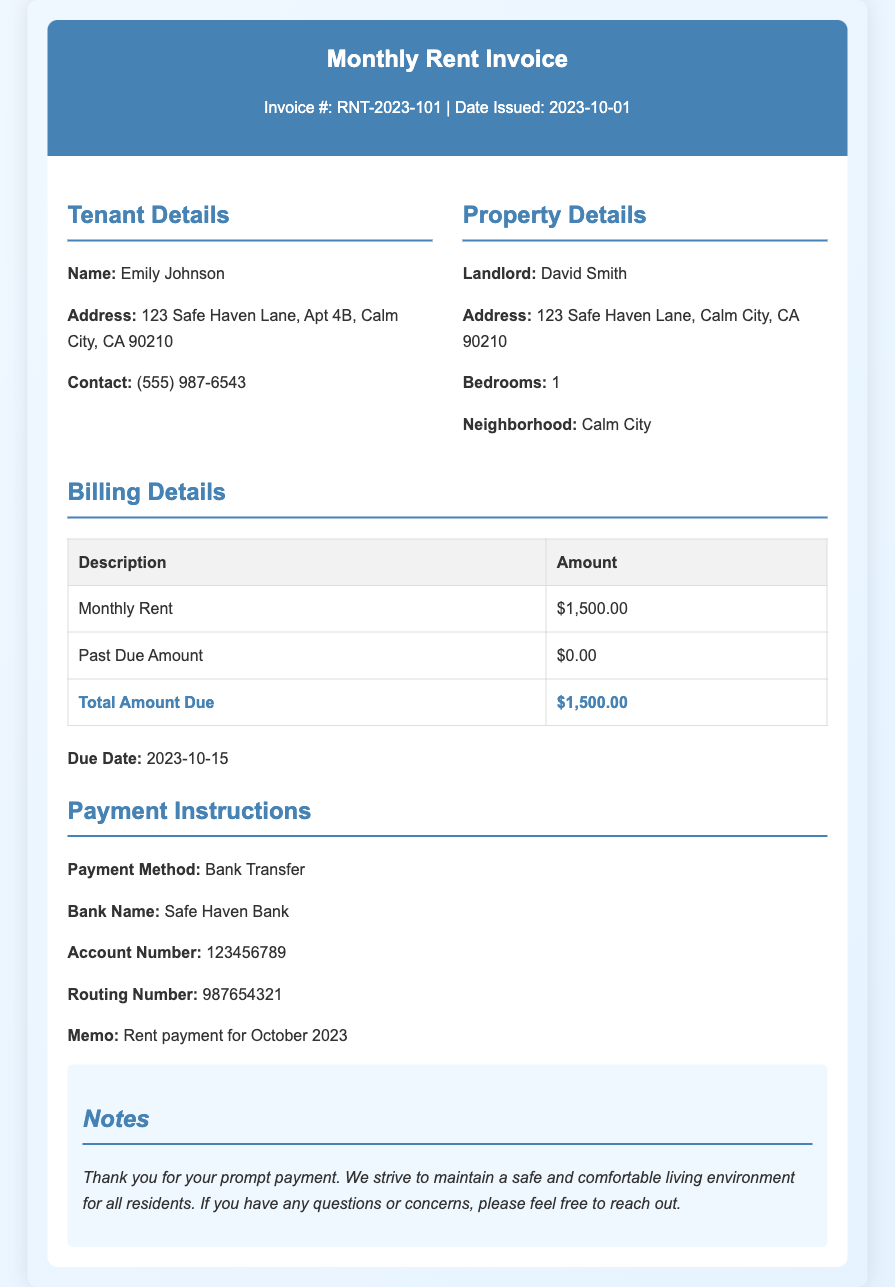What is the invoice number? The invoice number is clearly stated in the document, which is RNT-2023-101.
Answer: RNT-2023-101 What is the total amount due? The total amount due is listed in the billing details section, which shows $1,500.00.
Answer: $1,500.00 Who is the tenant? The tenant's name is provided in the tenant details section, which is Emily Johnson.
Answer: Emily Johnson What is the due date for the rent payment? The due date for the rent payment is specified in the document as 2023-10-15.
Answer: 2023-10-15 What is the monthly rent for the apartment? The document states that the monthly rent is $1,500.00.
Answer: $1,500.00 Is there a past due amount? The past due amount is indicated in the billing details, which shows $0.00.
Answer: $0.00 What payment method is required? The payment method is mentioned in the payment instructions as Bank Transfer.
Answer: Bank Transfer What is the landlord's name? The landlord's name is provided in the property details section as David Smith.
Answer: David Smith How many bedrooms does the apartment have? The number of bedrooms is mentioned in the property details, which is 1.
Answer: 1 